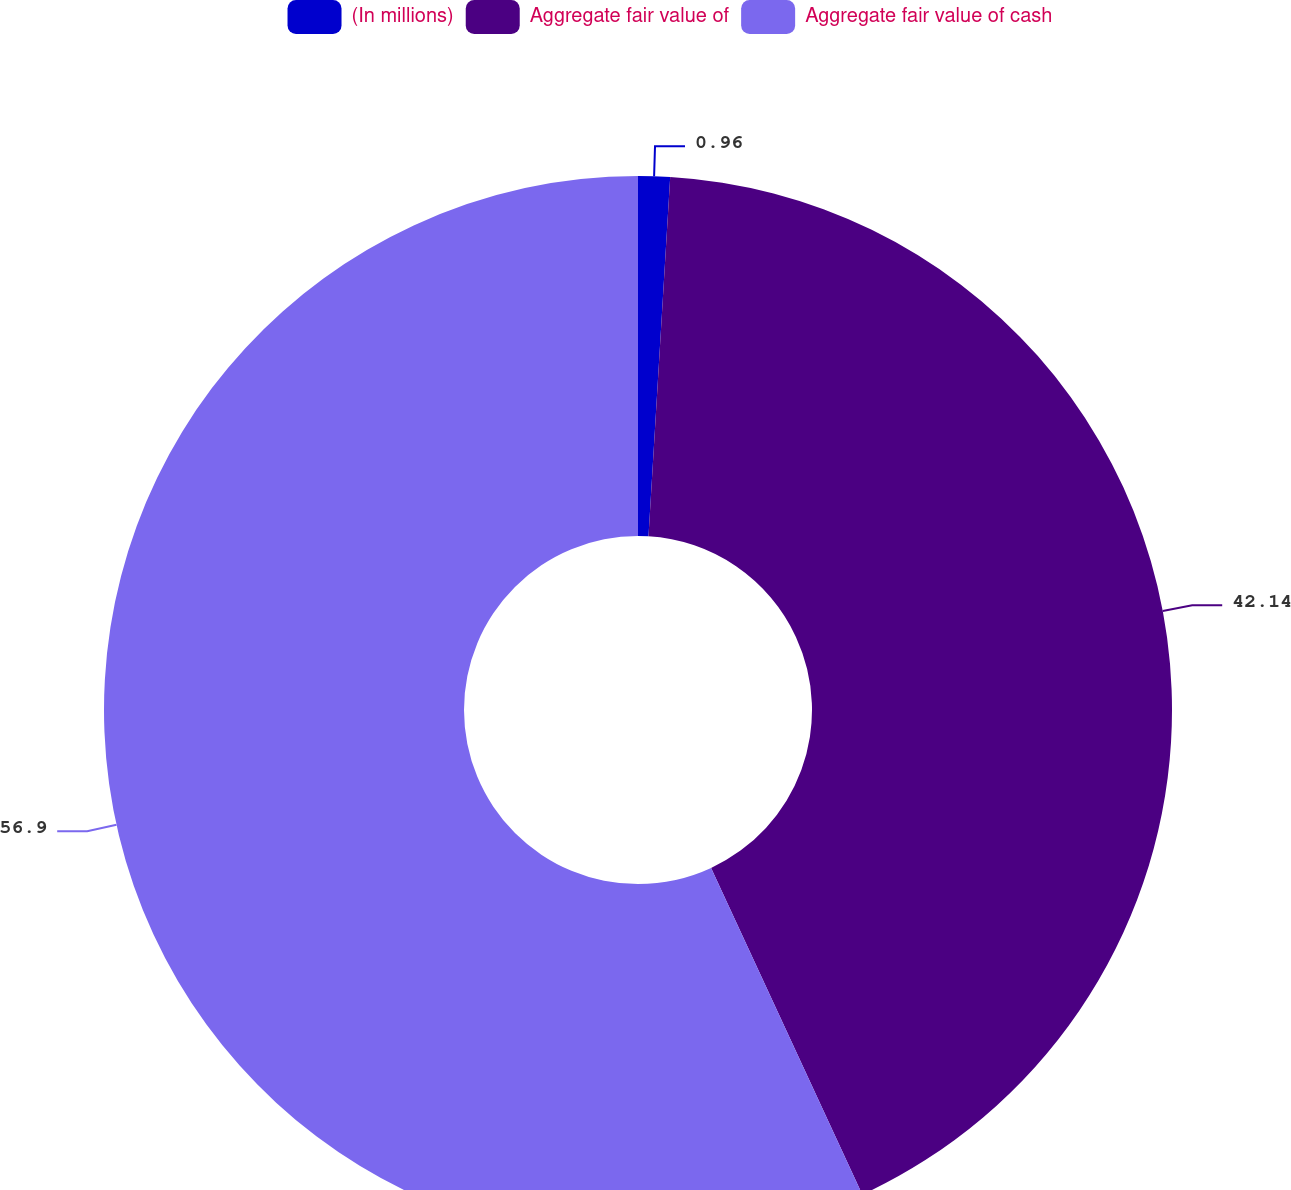Convert chart. <chart><loc_0><loc_0><loc_500><loc_500><pie_chart><fcel>(In millions)<fcel>Aggregate fair value of<fcel>Aggregate fair value of cash<nl><fcel>0.96%<fcel>42.14%<fcel>56.9%<nl></chart> 